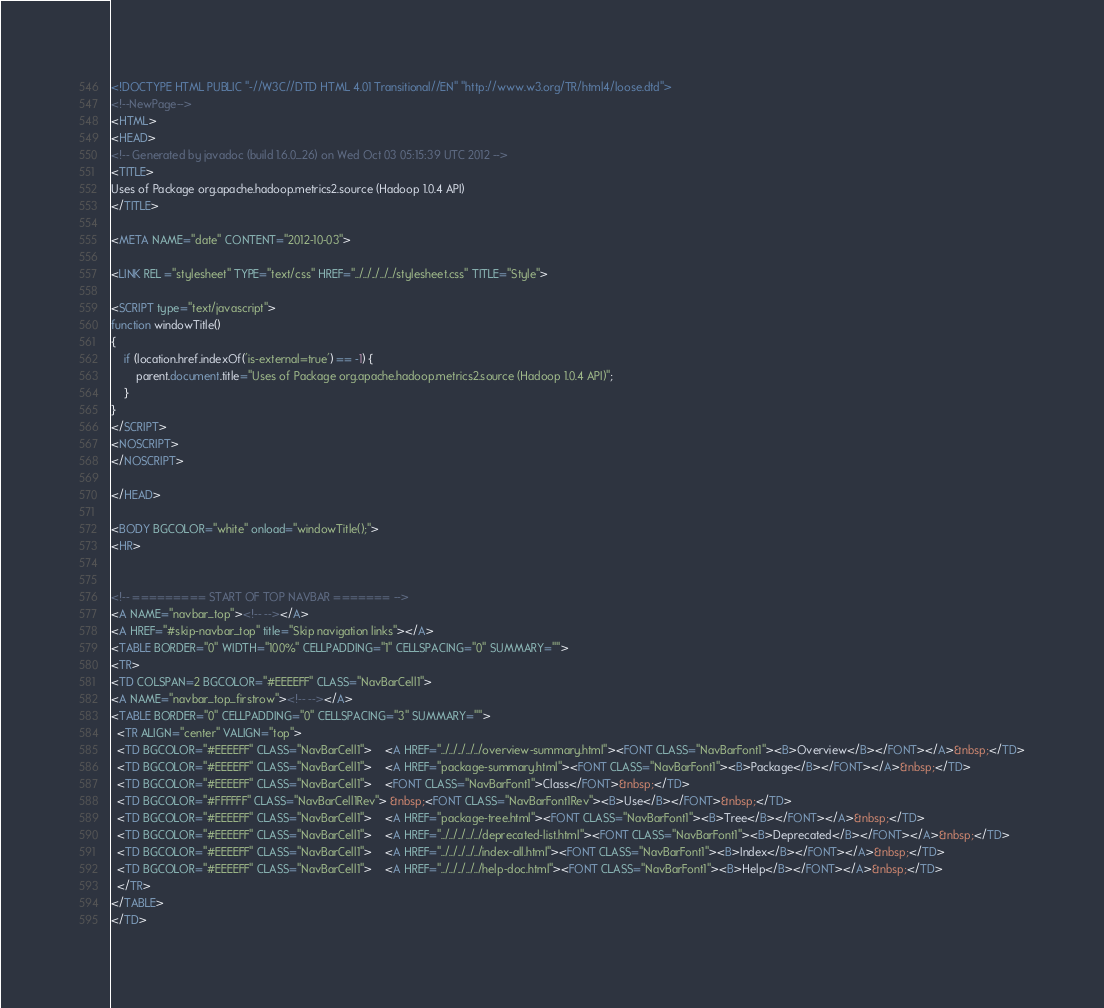Convert code to text. <code><loc_0><loc_0><loc_500><loc_500><_HTML_><!DOCTYPE HTML PUBLIC "-//W3C//DTD HTML 4.01 Transitional//EN" "http://www.w3.org/TR/html4/loose.dtd">
<!--NewPage-->
<HTML>
<HEAD>
<!-- Generated by javadoc (build 1.6.0_26) on Wed Oct 03 05:15:39 UTC 2012 -->
<TITLE>
Uses of Package org.apache.hadoop.metrics2.source (Hadoop 1.0.4 API)
</TITLE>

<META NAME="date" CONTENT="2012-10-03">

<LINK REL ="stylesheet" TYPE="text/css" HREF="../../../../../stylesheet.css" TITLE="Style">

<SCRIPT type="text/javascript">
function windowTitle()
{
    if (location.href.indexOf('is-external=true') == -1) {
        parent.document.title="Uses of Package org.apache.hadoop.metrics2.source (Hadoop 1.0.4 API)";
    }
}
</SCRIPT>
<NOSCRIPT>
</NOSCRIPT>

</HEAD>

<BODY BGCOLOR="white" onload="windowTitle();">
<HR>


<!-- ========= START OF TOP NAVBAR ======= -->
<A NAME="navbar_top"><!-- --></A>
<A HREF="#skip-navbar_top" title="Skip navigation links"></A>
<TABLE BORDER="0" WIDTH="100%" CELLPADDING="1" CELLSPACING="0" SUMMARY="">
<TR>
<TD COLSPAN=2 BGCOLOR="#EEEEFF" CLASS="NavBarCell1">
<A NAME="navbar_top_firstrow"><!-- --></A>
<TABLE BORDER="0" CELLPADDING="0" CELLSPACING="3" SUMMARY="">
  <TR ALIGN="center" VALIGN="top">
  <TD BGCOLOR="#EEEEFF" CLASS="NavBarCell1">    <A HREF="../../../../../overview-summary.html"><FONT CLASS="NavBarFont1"><B>Overview</B></FONT></A>&nbsp;</TD>
  <TD BGCOLOR="#EEEEFF" CLASS="NavBarCell1">    <A HREF="package-summary.html"><FONT CLASS="NavBarFont1"><B>Package</B></FONT></A>&nbsp;</TD>
  <TD BGCOLOR="#EEEEFF" CLASS="NavBarCell1">    <FONT CLASS="NavBarFont1">Class</FONT>&nbsp;</TD>
  <TD BGCOLOR="#FFFFFF" CLASS="NavBarCell1Rev"> &nbsp;<FONT CLASS="NavBarFont1Rev"><B>Use</B></FONT>&nbsp;</TD>
  <TD BGCOLOR="#EEEEFF" CLASS="NavBarCell1">    <A HREF="package-tree.html"><FONT CLASS="NavBarFont1"><B>Tree</B></FONT></A>&nbsp;</TD>
  <TD BGCOLOR="#EEEEFF" CLASS="NavBarCell1">    <A HREF="../../../../../deprecated-list.html"><FONT CLASS="NavBarFont1"><B>Deprecated</B></FONT></A>&nbsp;</TD>
  <TD BGCOLOR="#EEEEFF" CLASS="NavBarCell1">    <A HREF="../../../../../index-all.html"><FONT CLASS="NavBarFont1"><B>Index</B></FONT></A>&nbsp;</TD>
  <TD BGCOLOR="#EEEEFF" CLASS="NavBarCell1">    <A HREF="../../../../../help-doc.html"><FONT CLASS="NavBarFont1"><B>Help</B></FONT></A>&nbsp;</TD>
  </TR>
</TABLE>
</TD></code> 